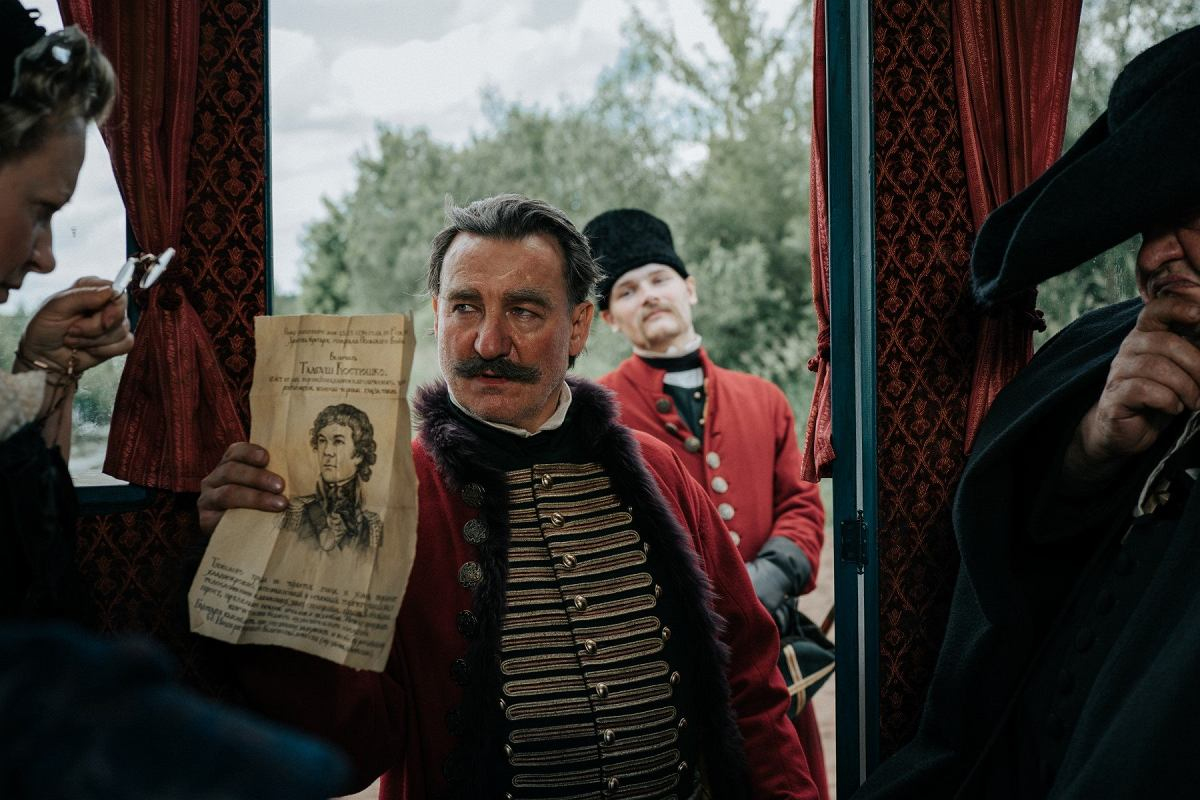Can you describe the significance of the uniforms worn by the characters? The uniforms worn by the characters are indicative of a specific military rank and unit from the 19th century, likely from Europe. The detailed gold epaulettes and the red sash signify a high-ranking officer, possibly illustrating a prestigious or elite unit. These uniforms not only provide clues about the social and military hierarchy but also enhance the visual authenticity and historical depth of the scene, reflecting the era's fashion and military codes. 